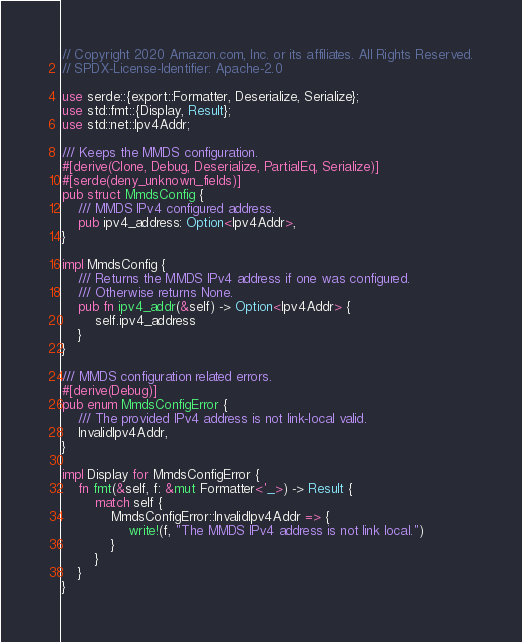Convert code to text. <code><loc_0><loc_0><loc_500><loc_500><_Rust_>// Copyright 2020 Amazon.com, Inc. or its affiliates. All Rights Reserved.
// SPDX-License-Identifier: Apache-2.0

use serde::{export::Formatter, Deserialize, Serialize};
use std::fmt::{Display, Result};
use std::net::Ipv4Addr;

/// Keeps the MMDS configuration.
#[derive(Clone, Debug, Deserialize, PartialEq, Serialize)]
#[serde(deny_unknown_fields)]
pub struct MmdsConfig {
    /// MMDS IPv4 configured address.
    pub ipv4_address: Option<Ipv4Addr>,
}

impl MmdsConfig {
    /// Returns the MMDS IPv4 address if one was configured.
    /// Otherwise returns None.
    pub fn ipv4_addr(&self) -> Option<Ipv4Addr> {
        self.ipv4_address
    }
}

/// MMDS configuration related errors.
#[derive(Debug)]
pub enum MmdsConfigError {
    /// The provided IPv4 address is not link-local valid.
    InvalidIpv4Addr,
}

impl Display for MmdsConfigError {
    fn fmt(&self, f: &mut Formatter<'_>) -> Result {
        match self {
            MmdsConfigError::InvalidIpv4Addr => {
                write!(f, "The MMDS IPv4 address is not link local.")
            }
        }
    }
}
</code> 